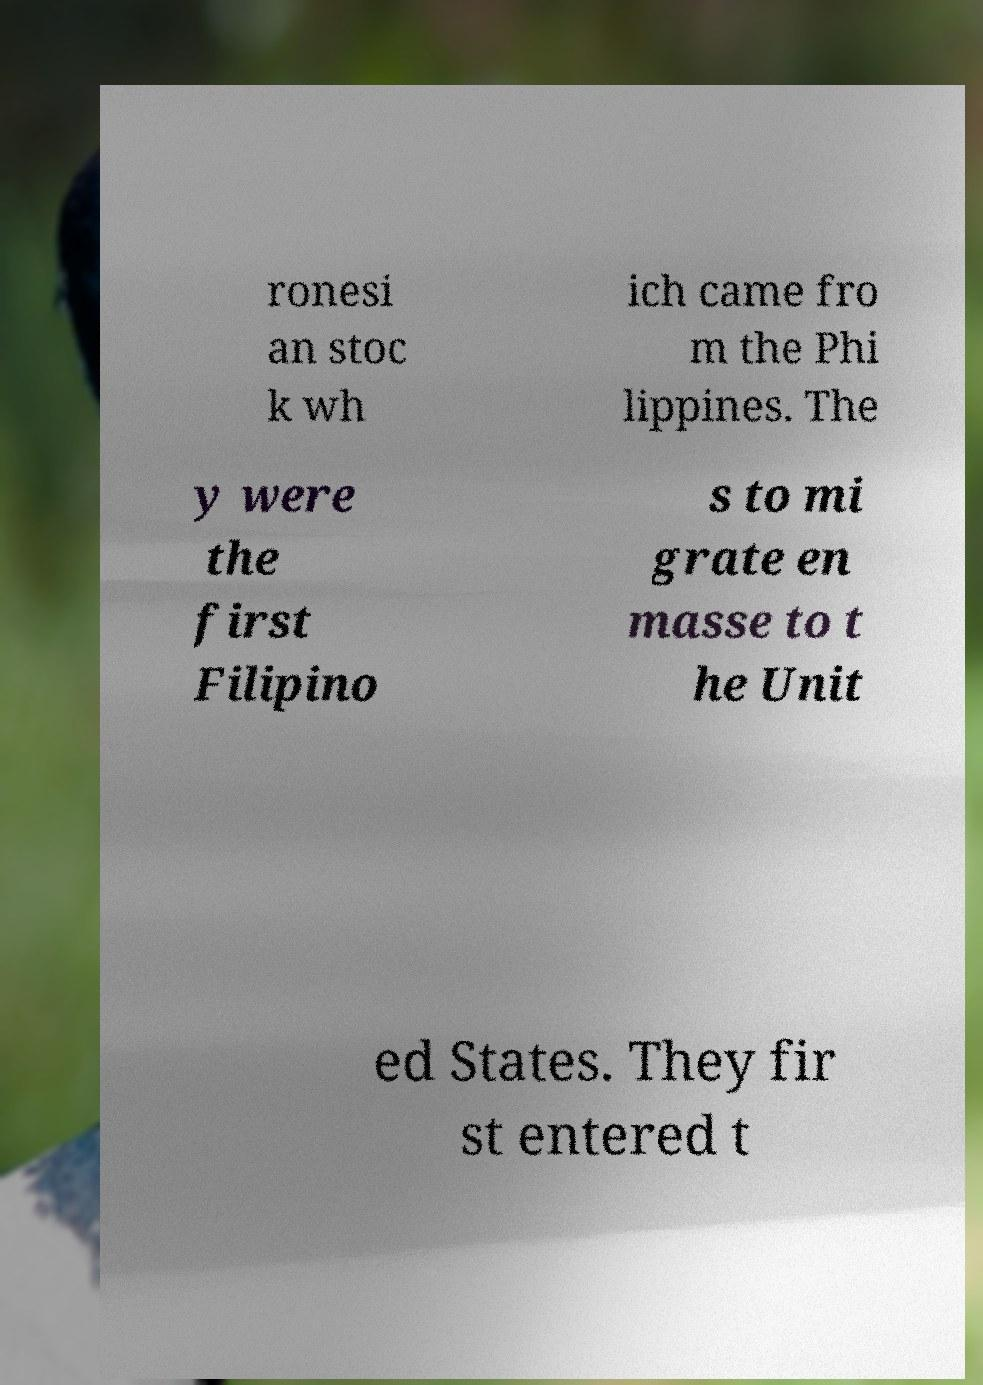Can you accurately transcribe the text from the provided image for me? ronesi an stoc k wh ich came fro m the Phi lippines. The y were the first Filipino s to mi grate en masse to t he Unit ed States. They fir st entered t 